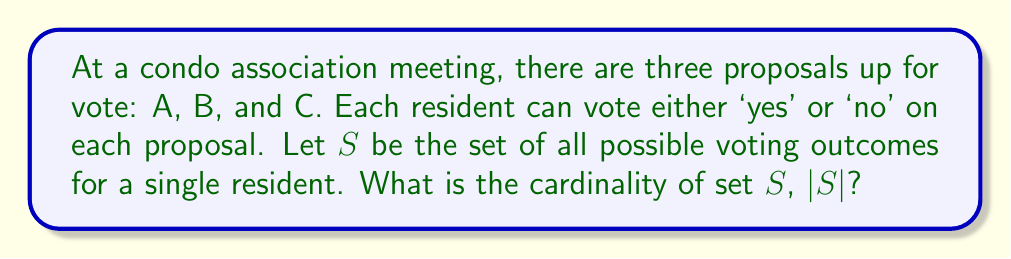Teach me how to tackle this problem. To solve this problem, let's approach it step-by-step:

1) For each proposal, a resident has two choices: 'yes' or 'no'.

2) We need to determine how many different combinations of votes are possible across all three proposals.

3) This scenario can be modeled using the multiplication principle of counting.

4) For proposal A, there are 2 choices.
   For proposal B, there are 2 choices.
   For proposal C, there are 2 choices.

5) The total number of possible voting outcomes is the product of these choices:

   $|S| = 2 \times 2 \times 2 = 2^3$

6) We can also think of this as a set of binary strings of length 3, where each position represents a proposal and can be either 0 (no) or 1 (yes).

7) The possible outcomes are:
   (0,0,0), (0,0,1), (0,1,0), (0,1,1), (1,0,0), (1,0,1), (1,1,0), (1,1,1)

8) Counting these outcomes confirms our calculation: there are 8 possible voting outcomes.

Therefore, the cardinality of set $S$ is 8.
Answer: $|S| = 8$ 